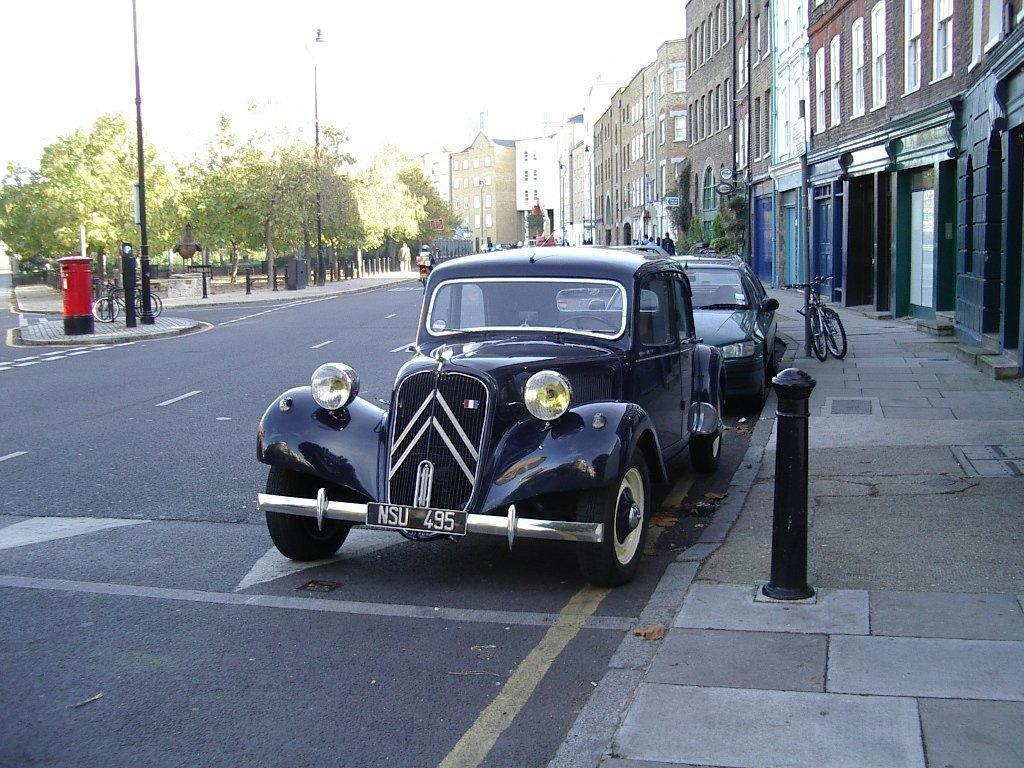In one or two sentences, can you explain what this image depicts? In this image we can see a road. On the side of the road there are vehicles. There is a sidewalk with a pole. Near to that there is a cycle. And there are buildings with windows. In the background there are trees. On the left side there is a letterbox. There are cycles and poles. In the background there is sky. 